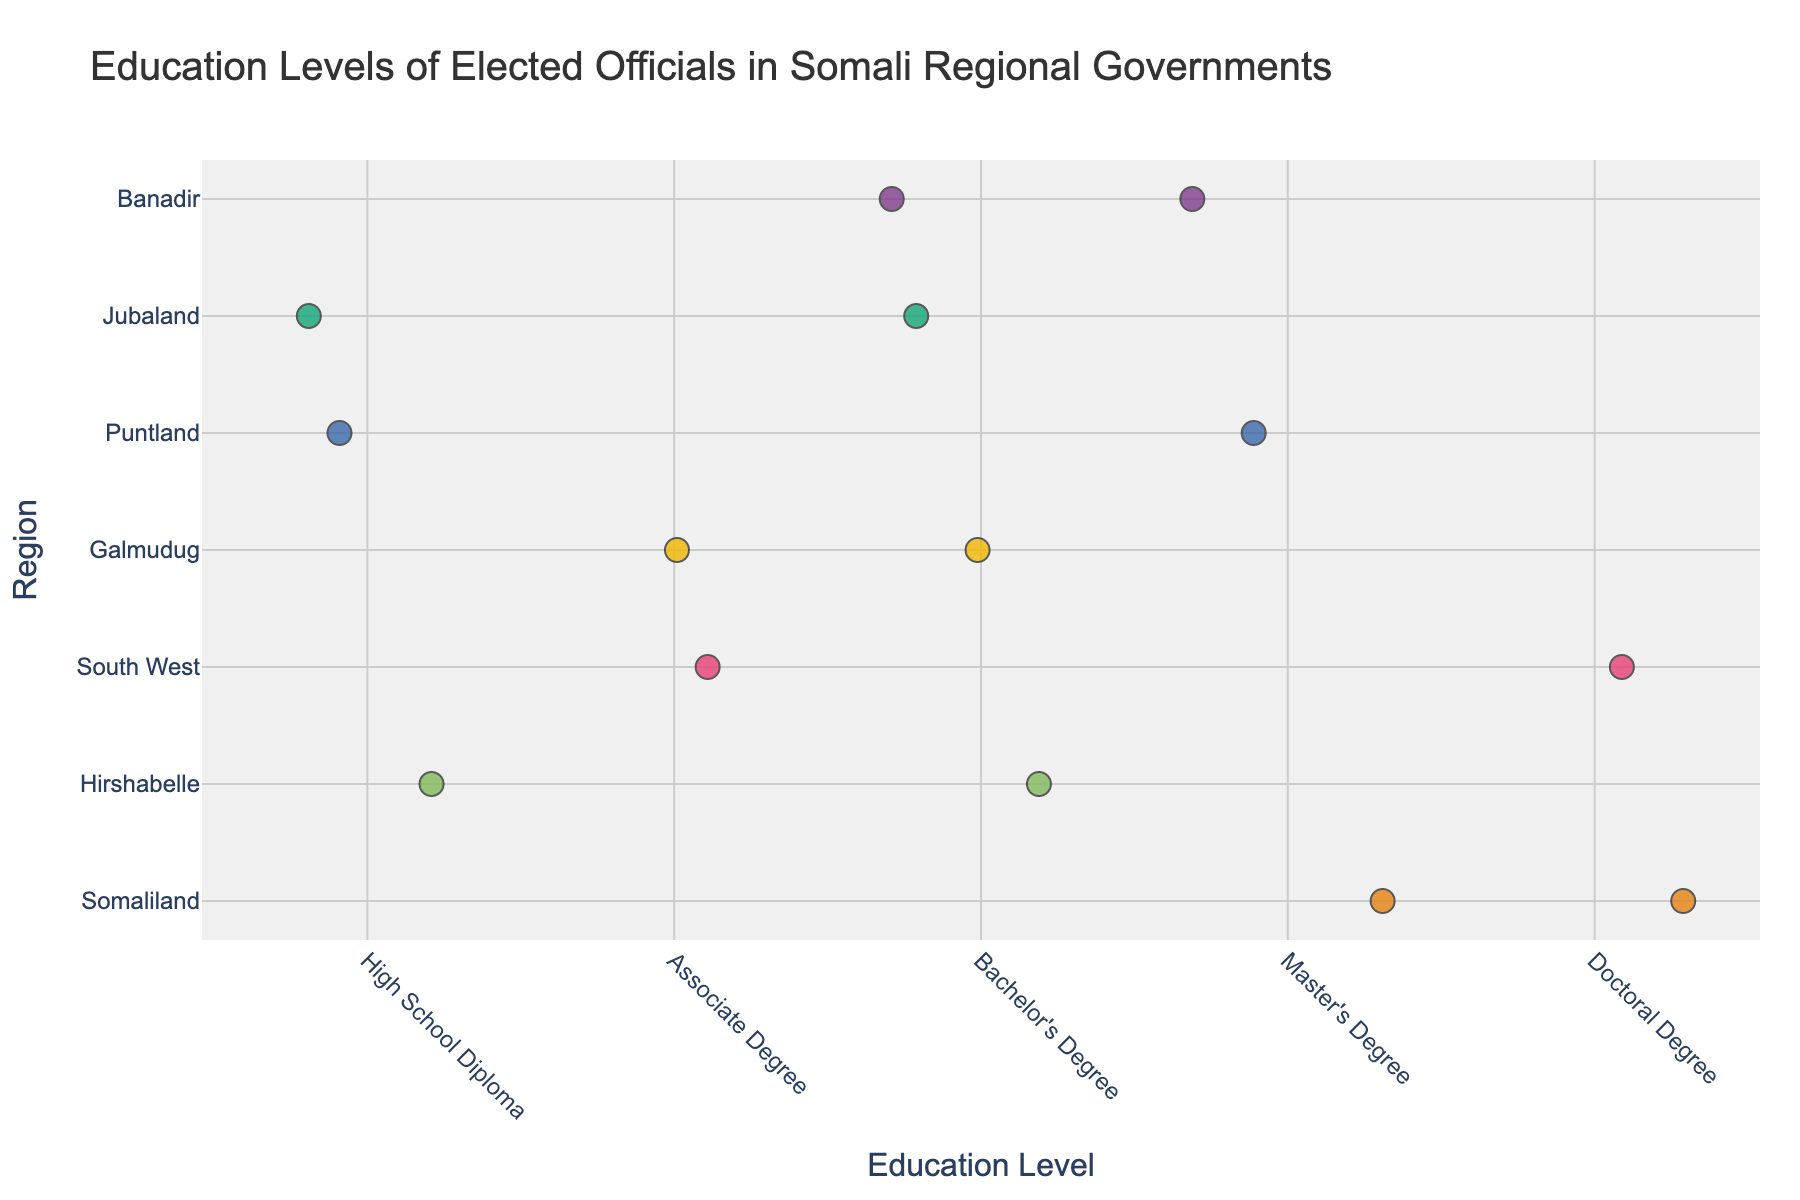what is the title of the plot? The title of the plot is displayed at the top and typically describes the data being shown. In this case, the title is "Education Levels of Elected Officials in Somali Regional Governments."
Answer: Education Levels of Elected Officials in Somali Regional Governments How many elected officials have a Bachelor's Degree? By looking at the "Bachelor's Degree" category on the x-axis, we can count the number of data points (markers) aligned with it. There are three officials with a Bachelor's Degree.
Answer: 3 Which region has the highest level of education represented? We need to see which region has the most data points in the "Doctoral Degree" category. Both South West and Somaliland have one official each with a Doctoral Degree, making them tied for the highest level of education represented.
Answer: South West and Somaliland In which regions do we see an official with an Associate Degree? Look at the "Associate Degree" category on the x-axis and identify the regions associated with the markers. Galmudug and South West have officials with an Associate Degree.
Answer: Galmudug and South West What is the most common education level among officials? To determine this, we need to look at which education level has the most data points (markers) on the x-axis. "Bachelor's Degree" has the most data points, with a total of three.
Answer: Bachelor's Degree How many regions have officials with a Master's Degree? By looking at the "Master's Degree" category on the x-axis, we can count the number of unique regions associated with it. There are three regions (Banadir, Puntland, and Somaliland) with officials having a Master's Degree.
Answer: 3 Which region has the most diverse range of education levels? To find the region with the most diverse range of education levels, we need to see which region has officials with different education categories. Banadir, with officials holding Bachelor's and Master's degrees, shows the most diversity.
Answer: Banadir How many elected officials have a high school diploma? By looking at the "High School Diploma" category on the x-axis, we can count the number of data points (markers) associated with it. There are three officials with a High School Diploma.
Answer: 3 What is the median education level in Hirshabelle? Among Hirshabelle officials, we need to find the median education level. The officials have a Bachelor's Degree and a High School Diploma. The median is the average of these two, which would be between a High School Diploma and a Bachelor's Degree. The Bachelor's Degree is a middle value.
Answer: Bachelor's Degree Is there a region where all officials have the same education level? To determine this, we need to check if any region has all its officials at a single education level. Banadir, with officials having both Bachelor's and Master's degrees, does not fit this criterion. None of the other regions have multiple officials with the same education level.
Answer: No 